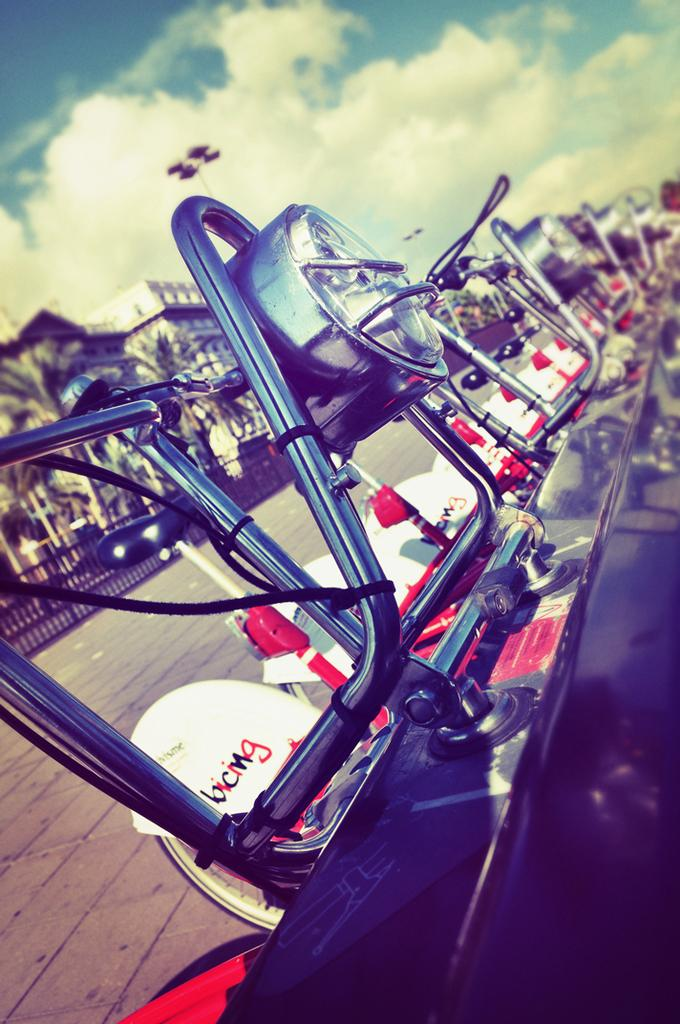What types of objects can be seen in the image? There are vehicles, rods, buildings, trees, a fence, light poles, and the sky visible in the image. Can you describe the background of the image? The background of the image includes buildings, trees, a fence, light poles, and the sky with clouds. What is the primary purpose of the rods in the image? The purpose of the rods in the image is not specified, but they could be used for various purposes such as support or decoration. What game is the father playing with the knife in the image? There is no game, father, or knife present in the image. 